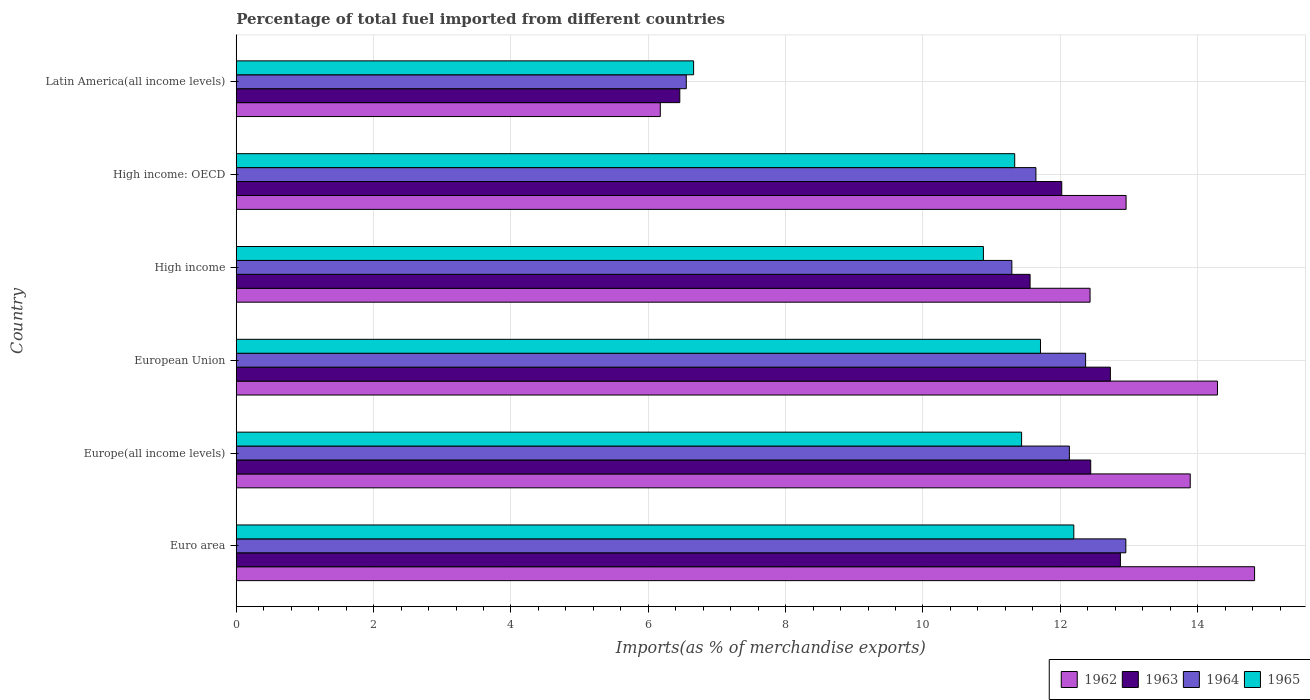How many different coloured bars are there?
Your answer should be very brief. 4. How many groups of bars are there?
Provide a short and direct response. 6. What is the percentage of imports to different countries in 1964 in Latin America(all income levels)?
Your answer should be very brief. 6.55. Across all countries, what is the maximum percentage of imports to different countries in 1965?
Keep it short and to the point. 12.2. Across all countries, what is the minimum percentage of imports to different countries in 1965?
Ensure brevity in your answer.  6.66. In which country was the percentage of imports to different countries in 1962 maximum?
Provide a succinct answer. Euro area. In which country was the percentage of imports to different countries in 1962 minimum?
Make the answer very short. Latin America(all income levels). What is the total percentage of imports to different countries in 1963 in the graph?
Your answer should be very brief. 68.09. What is the difference between the percentage of imports to different countries in 1962 in European Union and that in Latin America(all income levels)?
Keep it short and to the point. 8.11. What is the difference between the percentage of imports to different countries in 1965 in Latin America(all income levels) and the percentage of imports to different countries in 1962 in High income?
Your answer should be compact. -5.77. What is the average percentage of imports to different countries in 1963 per country?
Provide a short and direct response. 11.35. What is the difference between the percentage of imports to different countries in 1963 and percentage of imports to different countries in 1965 in Europe(all income levels)?
Your answer should be compact. 1.01. What is the ratio of the percentage of imports to different countries in 1964 in High income to that in Latin America(all income levels)?
Offer a terse response. 1.72. What is the difference between the highest and the second highest percentage of imports to different countries in 1964?
Offer a very short reply. 0.59. What is the difference between the highest and the lowest percentage of imports to different countries in 1965?
Your answer should be compact. 5.54. In how many countries, is the percentage of imports to different countries in 1965 greater than the average percentage of imports to different countries in 1965 taken over all countries?
Ensure brevity in your answer.  5. Is it the case that in every country, the sum of the percentage of imports to different countries in 1965 and percentage of imports to different countries in 1962 is greater than the sum of percentage of imports to different countries in 1963 and percentage of imports to different countries in 1964?
Your response must be concise. No. What does the 4th bar from the top in High income: OECD represents?
Give a very brief answer. 1962. What does the 2nd bar from the bottom in High income represents?
Your response must be concise. 1963. Is it the case that in every country, the sum of the percentage of imports to different countries in 1963 and percentage of imports to different countries in 1962 is greater than the percentage of imports to different countries in 1965?
Offer a very short reply. Yes. How many bars are there?
Make the answer very short. 24. How many countries are there in the graph?
Provide a succinct answer. 6. What is the difference between two consecutive major ticks on the X-axis?
Offer a terse response. 2. Does the graph contain any zero values?
Your answer should be compact. No. What is the title of the graph?
Offer a terse response. Percentage of total fuel imported from different countries. What is the label or title of the X-axis?
Your response must be concise. Imports(as % of merchandise exports). What is the label or title of the Y-axis?
Your response must be concise. Country. What is the Imports(as % of merchandise exports) in 1962 in Euro area?
Your answer should be compact. 14.83. What is the Imports(as % of merchandise exports) of 1963 in Euro area?
Your answer should be compact. 12.88. What is the Imports(as % of merchandise exports) of 1964 in Euro area?
Make the answer very short. 12.95. What is the Imports(as % of merchandise exports) in 1965 in Euro area?
Your answer should be compact. 12.2. What is the Imports(as % of merchandise exports) in 1962 in Europe(all income levels)?
Offer a very short reply. 13.89. What is the Imports(as % of merchandise exports) in 1963 in Europe(all income levels)?
Your answer should be very brief. 12.44. What is the Imports(as % of merchandise exports) in 1964 in Europe(all income levels)?
Make the answer very short. 12.13. What is the Imports(as % of merchandise exports) in 1965 in Europe(all income levels)?
Give a very brief answer. 11.44. What is the Imports(as % of merchandise exports) of 1962 in European Union?
Give a very brief answer. 14.29. What is the Imports(as % of merchandise exports) of 1963 in European Union?
Your answer should be compact. 12.73. What is the Imports(as % of merchandise exports) of 1964 in European Union?
Your answer should be compact. 12.37. What is the Imports(as % of merchandise exports) of 1965 in European Union?
Give a very brief answer. 11.71. What is the Imports(as % of merchandise exports) of 1962 in High income?
Your answer should be very brief. 12.43. What is the Imports(as % of merchandise exports) in 1963 in High income?
Offer a terse response. 11.56. What is the Imports(as % of merchandise exports) in 1964 in High income?
Provide a short and direct response. 11.29. What is the Imports(as % of merchandise exports) of 1965 in High income?
Keep it short and to the point. 10.88. What is the Imports(as % of merchandise exports) of 1962 in High income: OECD?
Offer a terse response. 12.96. What is the Imports(as % of merchandise exports) of 1963 in High income: OECD?
Give a very brief answer. 12.02. What is the Imports(as % of merchandise exports) in 1964 in High income: OECD?
Your answer should be compact. 11.64. What is the Imports(as % of merchandise exports) in 1965 in High income: OECD?
Your answer should be compact. 11.34. What is the Imports(as % of merchandise exports) of 1962 in Latin America(all income levels)?
Your response must be concise. 6.17. What is the Imports(as % of merchandise exports) in 1963 in Latin America(all income levels)?
Your answer should be very brief. 6.46. What is the Imports(as % of merchandise exports) of 1964 in Latin America(all income levels)?
Your answer should be very brief. 6.55. What is the Imports(as % of merchandise exports) of 1965 in Latin America(all income levels)?
Provide a short and direct response. 6.66. Across all countries, what is the maximum Imports(as % of merchandise exports) in 1962?
Provide a short and direct response. 14.83. Across all countries, what is the maximum Imports(as % of merchandise exports) in 1963?
Offer a very short reply. 12.88. Across all countries, what is the maximum Imports(as % of merchandise exports) in 1964?
Give a very brief answer. 12.95. Across all countries, what is the maximum Imports(as % of merchandise exports) in 1965?
Your response must be concise. 12.2. Across all countries, what is the minimum Imports(as % of merchandise exports) of 1962?
Provide a short and direct response. 6.17. Across all countries, what is the minimum Imports(as % of merchandise exports) of 1963?
Offer a terse response. 6.46. Across all countries, what is the minimum Imports(as % of merchandise exports) in 1964?
Offer a very short reply. 6.55. Across all countries, what is the minimum Imports(as % of merchandise exports) of 1965?
Offer a terse response. 6.66. What is the total Imports(as % of merchandise exports) in 1962 in the graph?
Your answer should be very brief. 74.58. What is the total Imports(as % of merchandise exports) in 1963 in the graph?
Your answer should be very brief. 68.09. What is the total Imports(as % of merchandise exports) in 1964 in the graph?
Provide a succinct answer. 66.95. What is the total Imports(as % of merchandise exports) of 1965 in the graph?
Your answer should be very brief. 64.22. What is the difference between the Imports(as % of merchandise exports) of 1962 in Euro area and that in Europe(all income levels)?
Provide a succinct answer. 0.94. What is the difference between the Imports(as % of merchandise exports) in 1963 in Euro area and that in Europe(all income levels)?
Ensure brevity in your answer.  0.43. What is the difference between the Imports(as % of merchandise exports) of 1964 in Euro area and that in Europe(all income levels)?
Offer a very short reply. 0.82. What is the difference between the Imports(as % of merchandise exports) of 1965 in Euro area and that in Europe(all income levels)?
Ensure brevity in your answer.  0.76. What is the difference between the Imports(as % of merchandise exports) in 1962 in Euro area and that in European Union?
Your answer should be compact. 0.54. What is the difference between the Imports(as % of merchandise exports) in 1963 in Euro area and that in European Union?
Your answer should be compact. 0.15. What is the difference between the Imports(as % of merchandise exports) of 1964 in Euro area and that in European Union?
Keep it short and to the point. 0.59. What is the difference between the Imports(as % of merchandise exports) in 1965 in Euro area and that in European Union?
Keep it short and to the point. 0.49. What is the difference between the Imports(as % of merchandise exports) of 1962 in Euro area and that in High income?
Keep it short and to the point. 2.4. What is the difference between the Imports(as % of merchandise exports) in 1963 in Euro area and that in High income?
Your response must be concise. 1.32. What is the difference between the Imports(as % of merchandise exports) in 1964 in Euro area and that in High income?
Your answer should be compact. 1.66. What is the difference between the Imports(as % of merchandise exports) in 1965 in Euro area and that in High income?
Ensure brevity in your answer.  1.32. What is the difference between the Imports(as % of merchandise exports) in 1962 in Euro area and that in High income: OECD?
Ensure brevity in your answer.  1.87. What is the difference between the Imports(as % of merchandise exports) of 1963 in Euro area and that in High income: OECD?
Your answer should be very brief. 0.85. What is the difference between the Imports(as % of merchandise exports) of 1964 in Euro area and that in High income: OECD?
Offer a terse response. 1.31. What is the difference between the Imports(as % of merchandise exports) in 1965 in Euro area and that in High income: OECD?
Your response must be concise. 0.86. What is the difference between the Imports(as % of merchandise exports) of 1962 in Euro area and that in Latin America(all income levels)?
Offer a very short reply. 8.65. What is the difference between the Imports(as % of merchandise exports) of 1963 in Euro area and that in Latin America(all income levels)?
Offer a terse response. 6.42. What is the difference between the Imports(as % of merchandise exports) of 1964 in Euro area and that in Latin America(all income levels)?
Ensure brevity in your answer.  6.4. What is the difference between the Imports(as % of merchandise exports) in 1965 in Euro area and that in Latin America(all income levels)?
Offer a very short reply. 5.54. What is the difference between the Imports(as % of merchandise exports) of 1962 in Europe(all income levels) and that in European Union?
Give a very brief answer. -0.4. What is the difference between the Imports(as % of merchandise exports) in 1963 in Europe(all income levels) and that in European Union?
Provide a short and direct response. -0.29. What is the difference between the Imports(as % of merchandise exports) of 1964 in Europe(all income levels) and that in European Union?
Ensure brevity in your answer.  -0.24. What is the difference between the Imports(as % of merchandise exports) of 1965 in Europe(all income levels) and that in European Union?
Provide a short and direct response. -0.27. What is the difference between the Imports(as % of merchandise exports) in 1962 in Europe(all income levels) and that in High income?
Offer a terse response. 1.46. What is the difference between the Imports(as % of merchandise exports) in 1963 in Europe(all income levels) and that in High income?
Your answer should be very brief. 0.88. What is the difference between the Imports(as % of merchandise exports) of 1964 in Europe(all income levels) and that in High income?
Keep it short and to the point. 0.84. What is the difference between the Imports(as % of merchandise exports) of 1965 in Europe(all income levels) and that in High income?
Provide a succinct answer. 0.56. What is the difference between the Imports(as % of merchandise exports) in 1962 in Europe(all income levels) and that in High income: OECD?
Your answer should be very brief. 0.93. What is the difference between the Imports(as % of merchandise exports) of 1963 in Europe(all income levels) and that in High income: OECD?
Keep it short and to the point. 0.42. What is the difference between the Imports(as % of merchandise exports) of 1964 in Europe(all income levels) and that in High income: OECD?
Ensure brevity in your answer.  0.49. What is the difference between the Imports(as % of merchandise exports) in 1965 in Europe(all income levels) and that in High income: OECD?
Offer a very short reply. 0.1. What is the difference between the Imports(as % of merchandise exports) in 1962 in Europe(all income levels) and that in Latin America(all income levels)?
Keep it short and to the point. 7.72. What is the difference between the Imports(as % of merchandise exports) of 1963 in Europe(all income levels) and that in Latin America(all income levels)?
Your answer should be very brief. 5.98. What is the difference between the Imports(as % of merchandise exports) in 1964 in Europe(all income levels) and that in Latin America(all income levels)?
Offer a very short reply. 5.58. What is the difference between the Imports(as % of merchandise exports) in 1965 in Europe(all income levels) and that in Latin America(all income levels)?
Make the answer very short. 4.78. What is the difference between the Imports(as % of merchandise exports) of 1962 in European Union and that in High income?
Provide a succinct answer. 1.86. What is the difference between the Imports(as % of merchandise exports) of 1963 in European Union and that in High income?
Keep it short and to the point. 1.17. What is the difference between the Imports(as % of merchandise exports) of 1964 in European Union and that in High income?
Ensure brevity in your answer.  1.07. What is the difference between the Imports(as % of merchandise exports) of 1965 in European Union and that in High income?
Make the answer very short. 0.83. What is the difference between the Imports(as % of merchandise exports) of 1962 in European Union and that in High income: OECD?
Offer a very short reply. 1.33. What is the difference between the Imports(as % of merchandise exports) in 1963 in European Union and that in High income: OECD?
Make the answer very short. 0.71. What is the difference between the Imports(as % of merchandise exports) in 1964 in European Union and that in High income: OECD?
Offer a terse response. 0.72. What is the difference between the Imports(as % of merchandise exports) in 1965 in European Union and that in High income: OECD?
Offer a terse response. 0.38. What is the difference between the Imports(as % of merchandise exports) in 1962 in European Union and that in Latin America(all income levels)?
Your answer should be very brief. 8.11. What is the difference between the Imports(as % of merchandise exports) of 1963 in European Union and that in Latin America(all income levels)?
Offer a very short reply. 6.27. What is the difference between the Imports(as % of merchandise exports) in 1964 in European Union and that in Latin America(all income levels)?
Keep it short and to the point. 5.82. What is the difference between the Imports(as % of merchandise exports) in 1965 in European Union and that in Latin America(all income levels)?
Offer a very short reply. 5.05. What is the difference between the Imports(as % of merchandise exports) of 1962 in High income and that in High income: OECD?
Your answer should be very brief. -0.52. What is the difference between the Imports(as % of merchandise exports) in 1963 in High income and that in High income: OECD?
Keep it short and to the point. -0.46. What is the difference between the Imports(as % of merchandise exports) in 1964 in High income and that in High income: OECD?
Your answer should be compact. -0.35. What is the difference between the Imports(as % of merchandise exports) of 1965 in High income and that in High income: OECD?
Give a very brief answer. -0.46. What is the difference between the Imports(as % of merchandise exports) in 1962 in High income and that in Latin America(all income levels)?
Offer a terse response. 6.26. What is the difference between the Imports(as % of merchandise exports) in 1963 in High income and that in Latin America(all income levels)?
Keep it short and to the point. 5.1. What is the difference between the Imports(as % of merchandise exports) of 1964 in High income and that in Latin America(all income levels)?
Provide a succinct answer. 4.74. What is the difference between the Imports(as % of merchandise exports) in 1965 in High income and that in Latin America(all income levels)?
Make the answer very short. 4.22. What is the difference between the Imports(as % of merchandise exports) of 1962 in High income: OECD and that in Latin America(all income levels)?
Your answer should be very brief. 6.78. What is the difference between the Imports(as % of merchandise exports) in 1963 in High income: OECD and that in Latin America(all income levels)?
Offer a terse response. 5.56. What is the difference between the Imports(as % of merchandise exports) in 1964 in High income: OECD and that in Latin America(all income levels)?
Your response must be concise. 5.09. What is the difference between the Imports(as % of merchandise exports) of 1965 in High income: OECD and that in Latin America(all income levels)?
Ensure brevity in your answer.  4.68. What is the difference between the Imports(as % of merchandise exports) of 1962 in Euro area and the Imports(as % of merchandise exports) of 1963 in Europe(all income levels)?
Offer a very short reply. 2.39. What is the difference between the Imports(as % of merchandise exports) of 1962 in Euro area and the Imports(as % of merchandise exports) of 1964 in Europe(all income levels)?
Offer a terse response. 2.7. What is the difference between the Imports(as % of merchandise exports) in 1962 in Euro area and the Imports(as % of merchandise exports) in 1965 in Europe(all income levels)?
Offer a terse response. 3.39. What is the difference between the Imports(as % of merchandise exports) of 1963 in Euro area and the Imports(as % of merchandise exports) of 1964 in Europe(all income levels)?
Provide a succinct answer. 0.74. What is the difference between the Imports(as % of merchandise exports) in 1963 in Euro area and the Imports(as % of merchandise exports) in 1965 in Europe(all income levels)?
Your answer should be compact. 1.44. What is the difference between the Imports(as % of merchandise exports) of 1964 in Euro area and the Imports(as % of merchandise exports) of 1965 in Europe(all income levels)?
Ensure brevity in your answer.  1.52. What is the difference between the Imports(as % of merchandise exports) of 1962 in Euro area and the Imports(as % of merchandise exports) of 1963 in European Union?
Make the answer very short. 2.1. What is the difference between the Imports(as % of merchandise exports) in 1962 in Euro area and the Imports(as % of merchandise exports) in 1964 in European Union?
Offer a very short reply. 2.46. What is the difference between the Imports(as % of merchandise exports) of 1962 in Euro area and the Imports(as % of merchandise exports) of 1965 in European Union?
Keep it short and to the point. 3.12. What is the difference between the Imports(as % of merchandise exports) in 1963 in Euro area and the Imports(as % of merchandise exports) in 1964 in European Union?
Your answer should be compact. 0.51. What is the difference between the Imports(as % of merchandise exports) of 1963 in Euro area and the Imports(as % of merchandise exports) of 1965 in European Union?
Your response must be concise. 1.16. What is the difference between the Imports(as % of merchandise exports) in 1964 in Euro area and the Imports(as % of merchandise exports) in 1965 in European Union?
Your response must be concise. 1.24. What is the difference between the Imports(as % of merchandise exports) of 1962 in Euro area and the Imports(as % of merchandise exports) of 1963 in High income?
Provide a short and direct response. 3.27. What is the difference between the Imports(as % of merchandise exports) in 1962 in Euro area and the Imports(as % of merchandise exports) in 1964 in High income?
Offer a very short reply. 3.53. What is the difference between the Imports(as % of merchandise exports) of 1962 in Euro area and the Imports(as % of merchandise exports) of 1965 in High income?
Make the answer very short. 3.95. What is the difference between the Imports(as % of merchandise exports) in 1963 in Euro area and the Imports(as % of merchandise exports) in 1964 in High income?
Provide a succinct answer. 1.58. What is the difference between the Imports(as % of merchandise exports) of 1963 in Euro area and the Imports(as % of merchandise exports) of 1965 in High income?
Make the answer very short. 2. What is the difference between the Imports(as % of merchandise exports) of 1964 in Euro area and the Imports(as % of merchandise exports) of 1965 in High income?
Offer a terse response. 2.07. What is the difference between the Imports(as % of merchandise exports) of 1962 in Euro area and the Imports(as % of merchandise exports) of 1963 in High income: OECD?
Keep it short and to the point. 2.81. What is the difference between the Imports(as % of merchandise exports) of 1962 in Euro area and the Imports(as % of merchandise exports) of 1964 in High income: OECD?
Your answer should be very brief. 3.18. What is the difference between the Imports(as % of merchandise exports) in 1962 in Euro area and the Imports(as % of merchandise exports) in 1965 in High income: OECD?
Ensure brevity in your answer.  3.49. What is the difference between the Imports(as % of merchandise exports) of 1963 in Euro area and the Imports(as % of merchandise exports) of 1964 in High income: OECD?
Provide a succinct answer. 1.23. What is the difference between the Imports(as % of merchandise exports) in 1963 in Euro area and the Imports(as % of merchandise exports) in 1965 in High income: OECD?
Your answer should be very brief. 1.54. What is the difference between the Imports(as % of merchandise exports) of 1964 in Euro area and the Imports(as % of merchandise exports) of 1965 in High income: OECD?
Give a very brief answer. 1.62. What is the difference between the Imports(as % of merchandise exports) of 1962 in Euro area and the Imports(as % of merchandise exports) of 1963 in Latin America(all income levels)?
Offer a terse response. 8.37. What is the difference between the Imports(as % of merchandise exports) of 1962 in Euro area and the Imports(as % of merchandise exports) of 1964 in Latin America(all income levels)?
Give a very brief answer. 8.28. What is the difference between the Imports(as % of merchandise exports) of 1962 in Euro area and the Imports(as % of merchandise exports) of 1965 in Latin America(all income levels)?
Your response must be concise. 8.17. What is the difference between the Imports(as % of merchandise exports) of 1963 in Euro area and the Imports(as % of merchandise exports) of 1964 in Latin America(all income levels)?
Your answer should be very brief. 6.32. What is the difference between the Imports(as % of merchandise exports) in 1963 in Euro area and the Imports(as % of merchandise exports) in 1965 in Latin America(all income levels)?
Your answer should be very brief. 6.22. What is the difference between the Imports(as % of merchandise exports) of 1964 in Euro area and the Imports(as % of merchandise exports) of 1965 in Latin America(all income levels)?
Give a very brief answer. 6.29. What is the difference between the Imports(as % of merchandise exports) of 1962 in Europe(all income levels) and the Imports(as % of merchandise exports) of 1963 in European Union?
Give a very brief answer. 1.16. What is the difference between the Imports(as % of merchandise exports) in 1962 in Europe(all income levels) and the Imports(as % of merchandise exports) in 1964 in European Union?
Your answer should be very brief. 1.52. What is the difference between the Imports(as % of merchandise exports) of 1962 in Europe(all income levels) and the Imports(as % of merchandise exports) of 1965 in European Union?
Ensure brevity in your answer.  2.18. What is the difference between the Imports(as % of merchandise exports) in 1963 in Europe(all income levels) and the Imports(as % of merchandise exports) in 1964 in European Union?
Your response must be concise. 0.07. What is the difference between the Imports(as % of merchandise exports) of 1963 in Europe(all income levels) and the Imports(as % of merchandise exports) of 1965 in European Union?
Your answer should be compact. 0.73. What is the difference between the Imports(as % of merchandise exports) in 1964 in Europe(all income levels) and the Imports(as % of merchandise exports) in 1965 in European Union?
Your answer should be compact. 0.42. What is the difference between the Imports(as % of merchandise exports) of 1962 in Europe(all income levels) and the Imports(as % of merchandise exports) of 1963 in High income?
Provide a short and direct response. 2.33. What is the difference between the Imports(as % of merchandise exports) in 1962 in Europe(all income levels) and the Imports(as % of merchandise exports) in 1964 in High income?
Make the answer very short. 2.6. What is the difference between the Imports(as % of merchandise exports) in 1962 in Europe(all income levels) and the Imports(as % of merchandise exports) in 1965 in High income?
Make the answer very short. 3.01. What is the difference between the Imports(as % of merchandise exports) of 1963 in Europe(all income levels) and the Imports(as % of merchandise exports) of 1964 in High income?
Ensure brevity in your answer.  1.15. What is the difference between the Imports(as % of merchandise exports) of 1963 in Europe(all income levels) and the Imports(as % of merchandise exports) of 1965 in High income?
Ensure brevity in your answer.  1.56. What is the difference between the Imports(as % of merchandise exports) of 1964 in Europe(all income levels) and the Imports(as % of merchandise exports) of 1965 in High income?
Keep it short and to the point. 1.25. What is the difference between the Imports(as % of merchandise exports) in 1962 in Europe(all income levels) and the Imports(as % of merchandise exports) in 1963 in High income: OECD?
Provide a succinct answer. 1.87. What is the difference between the Imports(as % of merchandise exports) in 1962 in Europe(all income levels) and the Imports(as % of merchandise exports) in 1964 in High income: OECD?
Your answer should be very brief. 2.25. What is the difference between the Imports(as % of merchandise exports) of 1962 in Europe(all income levels) and the Imports(as % of merchandise exports) of 1965 in High income: OECD?
Offer a terse response. 2.56. What is the difference between the Imports(as % of merchandise exports) in 1963 in Europe(all income levels) and the Imports(as % of merchandise exports) in 1964 in High income: OECD?
Offer a terse response. 0.8. What is the difference between the Imports(as % of merchandise exports) of 1963 in Europe(all income levels) and the Imports(as % of merchandise exports) of 1965 in High income: OECD?
Make the answer very short. 1.11. What is the difference between the Imports(as % of merchandise exports) in 1964 in Europe(all income levels) and the Imports(as % of merchandise exports) in 1965 in High income: OECD?
Your answer should be very brief. 0.8. What is the difference between the Imports(as % of merchandise exports) of 1962 in Europe(all income levels) and the Imports(as % of merchandise exports) of 1963 in Latin America(all income levels)?
Keep it short and to the point. 7.43. What is the difference between the Imports(as % of merchandise exports) in 1962 in Europe(all income levels) and the Imports(as % of merchandise exports) in 1964 in Latin America(all income levels)?
Offer a very short reply. 7.34. What is the difference between the Imports(as % of merchandise exports) of 1962 in Europe(all income levels) and the Imports(as % of merchandise exports) of 1965 in Latin America(all income levels)?
Provide a succinct answer. 7.23. What is the difference between the Imports(as % of merchandise exports) of 1963 in Europe(all income levels) and the Imports(as % of merchandise exports) of 1964 in Latin America(all income levels)?
Offer a very short reply. 5.89. What is the difference between the Imports(as % of merchandise exports) of 1963 in Europe(all income levels) and the Imports(as % of merchandise exports) of 1965 in Latin America(all income levels)?
Give a very brief answer. 5.78. What is the difference between the Imports(as % of merchandise exports) of 1964 in Europe(all income levels) and the Imports(as % of merchandise exports) of 1965 in Latin America(all income levels)?
Keep it short and to the point. 5.47. What is the difference between the Imports(as % of merchandise exports) in 1962 in European Union and the Imports(as % of merchandise exports) in 1963 in High income?
Your response must be concise. 2.73. What is the difference between the Imports(as % of merchandise exports) of 1962 in European Union and the Imports(as % of merchandise exports) of 1964 in High income?
Provide a short and direct response. 2.99. What is the difference between the Imports(as % of merchandise exports) of 1962 in European Union and the Imports(as % of merchandise exports) of 1965 in High income?
Your answer should be compact. 3.41. What is the difference between the Imports(as % of merchandise exports) in 1963 in European Union and the Imports(as % of merchandise exports) in 1964 in High income?
Give a very brief answer. 1.43. What is the difference between the Imports(as % of merchandise exports) of 1963 in European Union and the Imports(as % of merchandise exports) of 1965 in High income?
Ensure brevity in your answer.  1.85. What is the difference between the Imports(as % of merchandise exports) in 1964 in European Union and the Imports(as % of merchandise exports) in 1965 in High income?
Your answer should be compact. 1.49. What is the difference between the Imports(as % of merchandise exports) of 1962 in European Union and the Imports(as % of merchandise exports) of 1963 in High income: OECD?
Give a very brief answer. 2.27. What is the difference between the Imports(as % of merchandise exports) of 1962 in European Union and the Imports(as % of merchandise exports) of 1964 in High income: OECD?
Your response must be concise. 2.64. What is the difference between the Imports(as % of merchandise exports) in 1962 in European Union and the Imports(as % of merchandise exports) in 1965 in High income: OECD?
Offer a very short reply. 2.95. What is the difference between the Imports(as % of merchandise exports) in 1963 in European Union and the Imports(as % of merchandise exports) in 1964 in High income: OECD?
Provide a succinct answer. 1.08. What is the difference between the Imports(as % of merchandise exports) of 1963 in European Union and the Imports(as % of merchandise exports) of 1965 in High income: OECD?
Make the answer very short. 1.39. What is the difference between the Imports(as % of merchandise exports) in 1964 in European Union and the Imports(as % of merchandise exports) in 1965 in High income: OECD?
Offer a very short reply. 1.03. What is the difference between the Imports(as % of merchandise exports) of 1962 in European Union and the Imports(as % of merchandise exports) of 1963 in Latin America(all income levels)?
Offer a terse response. 7.83. What is the difference between the Imports(as % of merchandise exports) in 1962 in European Union and the Imports(as % of merchandise exports) in 1964 in Latin America(all income levels)?
Provide a succinct answer. 7.74. What is the difference between the Imports(as % of merchandise exports) of 1962 in European Union and the Imports(as % of merchandise exports) of 1965 in Latin America(all income levels)?
Offer a terse response. 7.63. What is the difference between the Imports(as % of merchandise exports) of 1963 in European Union and the Imports(as % of merchandise exports) of 1964 in Latin America(all income levels)?
Give a very brief answer. 6.18. What is the difference between the Imports(as % of merchandise exports) of 1963 in European Union and the Imports(as % of merchandise exports) of 1965 in Latin America(all income levels)?
Ensure brevity in your answer.  6.07. What is the difference between the Imports(as % of merchandise exports) of 1964 in European Union and the Imports(as % of merchandise exports) of 1965 in Latin America(all income levels)?
Your answer should be compact. 5.71. What is the difference between the Imports(as % of merchandise exports) in 1962 in High income and the Imports(as % of merchandise exports) in 1963 in High income: OECD?
Keep it short and to the point. 0.41. What is the difference between the Imports(as % of merchandise exports) in 1962 in High income and the Imports(as % of merchandise exports) in 1964 in High income: OECD?
Provide a short and direct response. 0.79. What is the difference between the Imports(as % of merchandise exports) in 1962 in High income and the Imports(as % of merchandise exports) in 1965 in High income: OECD?
Provide a short and direct response. 1.1. What is the difference between the Imports(as % of merchandise exports) of 1963 in High income and the Imports(as % of merchandise exports) of 1964 in High income: OECD?
Offer a terse response. -0.09. What is the difference between the Imports(as % of merchandise exports) of 1963 in High income and the Imports(as % of merchandise exports) of 1965 in High income: OECD?
Make the answer very short. 0.22. What is the difference between the Imports(as % of merchandise exports) of 1964 in High income and the Imports(as % of merchandise exports) of 1965 in High income: OECD?
Ensure brevity in your answer.  -0.04. What is the difference between the Imports(as % of merchandise exports) of 1962 in High income and the Imports(as % of merchandise exports) of 1963 in Latin America(all income levels)?
Give a very brief answer. 5.97. What is the difference between the Imports(as % of merchandise exports) in 1962 in High income and the Imports(as % of merchandise exports) in 1964 in Latin America(all income levels)?
Provide a short and direct response. 5.88. What is the difference between the Imports(as % of merchandise exports) of 1962 in High income and the Imports(as % of merchandise exports) of 1965 in Latin America(all income levels)?
Your response must be concise. 5.77. What is the difference between the Imports(as % of merchandise exports) of 1963 in High income and the Imports(as % of merchandise exports) of 1964 in Latin America(all income levels)?
Your answer should be compact. 5.01. What is the difference between the Imports(as % of merchandise exports) of 1963 in High income and the Imports(as % of merchandise exports) of 1965 in Latin America(all income levels)?
Your answer should be compact. 4.9. What is the difference between the Imports(as % of merchandise exports) of 1964 in High income and the Imports(as % of merchandise exports) of 1965 in Latin America(all income levels)?
Offer a terse response. 4.63. What is the difference between the Imports(as % of merchandise exports) of 1962 in High income: OECD and the Imports(as % of merchandise exports) of 1963 in Latin America(all income levels)?
Offer a very short reply. 6.5. What is the difference between the Imports(as % of merchandise exports) in 1962 in High income: OECD and the Imports(as % of merchandise exports) in 1964 in Latin America(all income levels)?
Make the answer very short. 6.4. What is the difference between the Imports(as % of merchandise exports) in 1962 in High income: OECD and the Imports(as % of merchandise exports) in 1965 in Latin America(all income levels)?
Keep it short and to the point. 6.3. What is the difference between the Imports(as % of merchandise exports) in 1963 in High income: OECD and the Imports(as % of merchandise exports) in 1964 in Latin America(all income levels)?
Keep it short and to the point. 5.47. What is the difference between the Imports(as % of merchandise exports) of 1963 in High income: OECD and the Imports(as % of merchandise exports) of 1965 in Latin America(all income levels)?
Provide a short and direct response. 5.36. What is the difference between the Imports(as % of merchandise exports) in 1964 in High income: OECD and the Imports(as % of merchandise exports) in 1965 in Latin America(all income levels)?
Offer a terse response. 4.98. What is the average Imports(as % of merchandise exports) in 1962 per country?
Offer a terse response. 12.43. What is the average Imports(as % of merchandise exports) in 1963 per country?
Keep it short and to the point. 11.35. What is the average Imports(as % of merchandise exports) of 1964 per country?
Provide a succinct answer. 11.16. What is the average Imports(as % of merchandise exports) in 1965 per country?
Provide a short and direct response. 10.7. What is the difference between the Imports(as % of merchandise exports) in 1962 and Imports(as % of merchandise exports) in 1963 in Euro area?
Offer a very short reply. 1.95. What is the difference between the Imports(as % of merchandise exports) in 1962 and Imports(as % of merchandise exports) in 1964 in Euro area?
Give a very brief answer. 1.87. What is the difference between the Imports(as % of merchandise exports) in 1962 and Imports(as % of merchandise exports) in 1965 in Euro area?
Make the answer very short. 2.63. What is the difference between the Imports(as % of merchandise exports) of 1963 and Imports(as % of merchandise exports) of 1964 in Euro area?
Ensure brevity in your answer.  -0.08. What is the difference between the Imports(as % of merchandise exports) of 1963 and Imports(as % of merchandise exports) of 1965 in Euro area?
Your answer should be very brief. 0.68. What is the difference between the Imports(as % of merchandise exports) in 1964 and Imports(as % of merchandise exports) in 1965 in Euro area?
Provide a succinct answer. 0.76. What is the difference between the Imports(as % of merchandise exports) of 1962 and Imports(as % of merchandise exports) of 1963 in Europe(all income levels)?
Provide a succinct answer. 1.45. What is the difference between the Imports(as % of merchandise exports) of 1962 and Imports(as % of merchandise exports) of 1964 in Europe(all income levels)?
Make the answer very short. 1.76. What is the difference between the Imports(as % of merchandise exports) of 1962 and Imports(as % of merchandise exports) of 1965 in Europe(all income levels)?
Offer a very short reply. 2.46. What is the difference between the Imports(as % of merchandise exports) in 1963 and Imports(as % of merchandise exports) in 1964 in Europe(all income levels)?
Offer a terse response. 0.31. What is the difference between the Imports(as % of merchandise exports) of 1963 and Imports(as % of merchandise exports) of 1965 in Europe(all income levels)?
Offer a terse response. 1.01. What is the difference between the Imports(as % of merchandise exports) of 1964 and Imports(as % of merchandise exports) of 1965 in Europe(all income levels)?
Ensure brevity in your answer.  0.7. What is the difference between the Imports(as % of merchandise exports) of 1962 and Imports(as % of merchandise exports) of 1963 in European Union?
Offer a terse response. 1.56. What is the difference between the Imports(as % of merchandise exports) of 1962 and Imports(as % of merchandise exports) of 1964 in European Union?
Provide a succinct answer. 1.92. What is the difference between the Imports(as % of merchandise exports) in 1962 and Imports(as % of merchandise exports) in 1965 in European Union?
Your answer should be compact. 2.58. What is the difference between the Imports(as % of merchandise exports) in 1963 and Imports(as % of merchandise exports) in 1964 in European Union?
Your response must be concise. 0.36. What is the difference between the Imports(as % of merchandise exports) of 1963 and Imports(as % of merchandise exports) of 1965 in European Union?
Keep it short and to the point. 1.02. What is the difference between the Imports(as % of merchandise exports) in 1964 and Imports(as % of merchandise exports) in 1965 in European Union?
Keep it short and to the point. 0.66. What is the difference between the Imports(as % of merchandise exports) of 1962 and Imports(as % of merchandise exports) of 1963 in High income?
Your answer should be compact. 0.87. What is the difference between the Imports(as % of merchandise exports) in 1962 and Imports(as % of merchandise exports) in 1964 in High income?
Ensure brevity in your answer.  1.14. What is the difference between the Imports(as % of merchandise exports) of 1962 and Imports(as % of merchandise exports) of 1965 in High income?
Provide a succinct answer. 1.55. What is the difference between the Imports(as % of merchandise exports) of 1963 and Imports(as % of merchandise exports) of 1964 in High income?
Offer a very short reply. 0.27. What is the difference between the Imports(as % of merchandise exports) of 1963 and Imports(as % of merchandise exports) of 1965 in High income?
Ensure brevity in your answer.  0.68. What is the difference between the Imports(as % of merchandise exports) in 1964 and Imports(as % of merchandise exports) in 1965 in High income?
Make the answer very short. 0.41. What is the difference between the Imports(as % of merchandise exports) of 1962 and Imports(as % of merchandise exports) of 1963 in High income: OECD?
Your answer should be very brief. 0.94. What is the difference between the Imports(as % of merchandise exports) of 1962 and Imports(as % of merchandise exports) of 1964 in High income: OECD?
Keep it short and to the point. 1.31. What is the difference between the Imports(as % of merchandise exports) in 1962 and Imports(as % of merchandise exports) in 1965 in High income: OECD?
Offer a very short reply. 1.62. What is the difference between the Imports(as % of merchandise exports) of 1963 and Imports(as % of merchandise exports) of 1964 in High income: OECD?
Ensure brevity in your answer.  0.38. What is the difference between the Imports(as % of merchandise exports) in 1963 and Imports(as % of merchandise exports) in 1965 in High income: OECD?
Ensure brevity in your answer.  0.69. What is the difference between the Imports(as % of merchandise exports) of 1964 and Imports(as % of merchandise exports) of 1965 in High income: OECD?
Offer a terse response. 0.31. What is the difference between the Imports(as % of merchandise exports) in 1962 and Imports(as % of merchandise exports) in 1963 in Latin America(all income levels)?
Make the answer very short. -0.28. What is the difference between the Imports(as % of merchandise exports) of 1962 and Imports(as % of merchandise exports) of 1964 in Latin America(all income levels)?
Offer a terse response. -0.38. What is the difference between the Imports(as % of merchandise exports) of 1962 and Imports(as % of merchandise exports) of 1965 in Latin America(all income levels)?
Your response must be concise. -0.48. What is the difference between the Imports(as % of merchandise exports) of 1963 and Imports(as % of merchandise exports) of 1964 in Latin America(all income levels)?
Your response must be concise. -0.09. What is the difference between the Imports(as % of merchandise exports) in 1963 and Imports(as % of merchandise exports) in 1965 in Latin America(all income levels)?
Make the answer very short. -0.2. What is the difference between the Imports(as % of merchandise exports) in 1964 and Imports(as % of merchandise exports) in 1965 in Latin America(all income levels)?
Offer a very short reply. -0.11. What is the ratio of the Imports(as % of merchandise exports) of 1962 in Euro area to that in Europe(all income levels)?
Offer a very short reply. 1.07. What is the ratio of the Imports(as % of merchandise exports) of 1963 in Euro area to that in Europe(all income levels)?
Keep it short and to the point. 1.03. What is the ratio of the Imports(as % of merchandise exports) of 1964 in Euro area to that in Europe(all income levels)?
Give a very brief answer. 1.07. What is the ratio of the Imports(as % of merchandise exports) of 1965 in Euro area to that in Europe(all income levels)?
Keep it short and to the point. 1.07. What is the ratio of the Imports(as % of merchandise exports) in 1962 in Euro area to that in European Union?
Provide a succinct answer. 1.04. What is the ratio of the Imports(as % of merchandise exports) of 1963 in Euro area to that in European Union?
Make the answer very short. 1.01. What is the ratio of the Imports(as % of merchandise exports) of 1964 in Euro area to that in European Union?
Offer a very short reply. 1.05. What is the ratio of the Imports(as % of merchandise exports) of 1965 in Euro area to that in European Union?
Make the answer very short. 1.04. What is the ratio of the Imports(as % of merchandise exports) of 1962 in Euro area to that in High income?
Your answer should be very brief. 1.19. What is the ratio of the Imports(as % of merchandise exports) in 1963 in Euro area to that in High income?
Provide a short and direct response. 1.11. What is the ratio of the Imports(as % of merchandise exports) of 1964 in Euro area to that in High income?
Offer a terse response. 1.15. What is the ratio of the Imports(as % of merchandise exports) in 1965 in Euro area to that in High income?
Your answer should be compact. 1.12. What is the ratio of the Imports(as % of merchandise exports) of 1962 in Euro area to that in High income: OECD?
Offer a terse response. 1.14. What is the ratio of the Imports(as % of merchandise exports) of 1963 in Euro area to that in High income: OECD?
Offer a terse response. 1.07. What is the ratio of the Imports(as % of merchandise exports) of 1964 in Euro area to that in High income: OECD?
Ensure brevity in your answer.  1.11. What is the ratio of the Imports(as % of merchandise exports) of 1965 in Euro area to that in High income: OECD?
Offer a terse response. 1.08. What is the ratio of the Imports(as % of merchandise exports) of 1962 in Euro area to that in Latin America(all income levels)?
Your answer should be compact. 2.4. What is the ratio of the Imports(as % of merchandise exports) in 1963 in Euro area to that in Latin America(all income levels)?
Offer a very short reply. 1.99. What is the ratio of the Imports(as % of merchandise exports) in 1964 in Euro area to that in Latin America(all income levels)?
Provide a short and direct response. 1.98. What is the ratio of the Imports(as % of merchandise exports) of 1965 in Euro area to that in Latin America(all income levels)?
Keep it short and to the point. 1.83. What is the ratio of the Imports(as % of merchandise exports) in 1962 in Europe(all income levels) to that in European Union?
Make the answer very short. 0.97. What is the ratio of the Imports(as % of merchandise exports) of 1963 in Europe(all income levels) to that in European Union?
Your answer should be very brief. 0.98. What is the ratio of the Imports(as % of merchandise exports) in 1964 in Europe(all income levels) to that in European Union?
Your answer should be very brief. 0.98. What is the ratio of the Imports(as % of merchandise exports) of 1965 in Europe(all income levels) to that in European Union?
Make the answer very short. 0.98. What is the ratio of the Imports(as % of merchandise exports) of 1962 in Europe(all income levels) to that in High income?
Make the answer very short. 1.12. What is the ratio of the Imports(as % of merchandise exports) in 1963 in Europe(all income levels) to that in High income?
Provide a succinct answer. 1.08. What is the ratio of the Imports(as % of merchandise exports) of 1964 in Europe(all income levels) to that in High income?
Offer a very short reply. 1.07. What is the ratio of the Imports(as % of merchandise exports) of 1965 in Europe(all income levels) to that in High income?
Your answer should be compact. 1.05. What is the ratio of the Imports(as % of merchandise exports) in 1962 in Europe(all income levels) to that in High income: OECD?
Ensure brevity in your answer.  1.07. What is the ratio of the Imports(as % of merchandise exports) of 1963 in Europe(all income levels) to that in High income: OECD?
Make the answer very short. 1.04. What is the ratio of the Imports(as % of merchandise exports) in 1964 in Europe(all income levels) to that in High income: OECD?
Your answer should be very brief. 1.04. What is the ratio of the Imports(as % of merchandise exports) in 1965 in Europe(all income levels) to that in High income: OECD?
Provide a succinct answer. 1.01. What is the ratio of the Imports(as % of merchandise exports) in 1962 in Europe(all income levels) to that in Latin America(all income levels)?
Your answer should be compact. 2.25. What is the ratio of the Imports(as % of merchandise exports) of 1963 in Europe(all income levels) to that in Latin America(all income levels)?
Provide a succinct answer. 1.93. What is the ratio of the Imports(as % of merchandise exports) in 1964 in Europe(all income levels) to that in Latin America(all income levels)?
Keep it short and to the point. 1.85. What is the ratio of the Imports(as % of merchandise exports) in 1965 in Europe(all income levels) to that in Latin America(all income levels)?
Keep it short and to the point. 1.72. What is the ratio of the Imports(as % of merchandise exports) in 1962 in European Union to that in High income?
Your answer should be very brief. 1.15. What is the ratio of the Imports(as % of merchandise exports) in 1963 in European Union to that in High income?
Keep it short and to the point. 1.1. What is the ratio of the Imports(as % of merchandise exports) in 1964 in European Union to that in High income?
Your answer should be very brief. 1.1. What is the ratio of the Imports(as % of merchandise exports) of 1965 in European Union to that in High income?
Provide a succinct answer. 1.08. What is the ratio of the Imports(as % of merchandise exports) in 1962 in European Union to that in High income: OECD?
Make the answer very short. 1.1. What is the ratio of the Imports(as % of merchandise exports) of 1963 in European Union to that in High income: OECD?
Offer a very short reply. 1.06. What is the ratio of the Imports(as % of merchandise exports) of 1964 in European Union to that in High income: OECD?
Make the answer very short. 1.06. What is the ratio of the Imports(as % of merchandise exports) of 1965 in European Union to that in High income: OECD?
Your answer should be compact. 1.03. What is the ratio of the Imports(as % of merchandise exports) in 1962 in European Union to that in Latin America(all income levels)?
Give a very brief answer. 2.31. What is the ratio of the Imports(as % of merchandise exports) of 1963 in European Union to that in Latin America(all income levels)?
Offer a terse response. 1.97. What is the ratio of the Imports(as % of merchandise exports) in 1964 in European Union to that in Latin America(all income levels)?
Keep it short and to the point. 1.89. What is the ratio of the Imports(as % of merchandise exports) in 1965 in European Union to that in Latin America(all income levels)?
Provide a succinct answer. 1.76. What is the ratio of the Imports(as % of merchandise exports) of 1962 in High income to that in High income: OECD?
Keep it short and to the point. 0.96. What is the ratio of the Imports(as % of merchandise exports) of 1963 in High income to that in High income: OECD?
Your response must be concise. 0.96. What is the ratio of the Imports(as % of merchandise exports) of 1964 in High income to that in High income: OECD?
Your response must be concise. 0.97. What is the ratio of the Imports(as % of merchandise exports) in 1965 in High income to that in High income: OECD?
Make the answer very short. 0.96. What is the ratio of the Imports(as % of merchandise exports) of 1962 in High income to that in Latin America(all income levels)?
Provide a short and direct response. 2.01. What is the ratio of the Imports(as % of merchandise exports) in 1963 in High income to that in Latin America(all income levels)?
Give a very brief answer. 1.79. What is the ratio of the Imports(as % of merchandise exports) of 1964 in High income to that in Latin America(all income levels)?
Your response must be concise. 1.72. What is the ratio of the Imports(as % of merchandise exports) in 1965 in High income to that in Latin America(all income levels)?
Keep it short and to the point. 1.63. What is the ratio of the Imports(as % of merchandise exports) of 1962 in High income: OECD to that in Latin America(all income levels)?
Offer a terse response. 2.1. What is the ratio of the Imports(as % of merchandise exports) of 1963 in High income: OECD to that in Latin America(all income levels)?
Ensure brevity in your answer.  1.86. What is the ratio of the Imports(as % of merchandise exports) in 1964 in High income: OECD to that in Latin America(all income levels)?
Give a very brief answer. 1.78. What is the ratio of the Imports(as % of merchandise exports) of 1965 in High income: OECD to that in Latin America(all income levels)?
Ensure brevity in your answer.  1.7. What is the difference between the highest and the second highest Imports(as % of merchandise exports) in 1962?
Make the answer very short. 0.54. What is the difference between the highest and the second highest Imports(as % of merchandise exports) in 1963?
Make the answer very short. 0.15. What is the difference between the highest and the second highest Imports(as % of merchandise exports) of 1964?
Provide a succinct answer. 0.59. What is the difference between the highest and the second highest Imports(as % of merchandise exports) of 1965?
Provide a succinct answer. 0.49. What is the difference between the highest and the lowest Imports(as % of merchandise exports) of 1962?
Provide a short and direct response. 8.65. What is the difference between the highest and the lowest Imports(as % of merchandise exports) of 1963?
Keep it short and to the point. 6.42. What is the difference between the highest and the lowest Imports(as % of merchandise exports) in 1964?
Offer a terse response. 6.4. What is the difference between the highest and the lowest Imports(as % of merchandise exports) in 1965?
Ensure brevity in your answer.  5.54. 